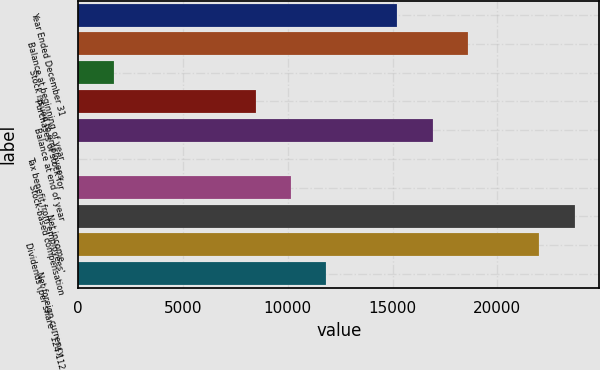Convert chart. <chart><loc_0><loc_0><loc_500><loc_500><bar_chart><fcel>Year Ended December 31<fcel>Balance at beginning of year<fcel>Stock issued to employees<fcel>Purchases of stock for<fcel>Balance at end of year<fcel>Tax benefit from employees'<fcel>Stock-based compensation<fcel>Net income<fcel>Dividends (per share - 124 112<fcel>Net foreign currency<nl><fcel>15228.3<fcel>18611.7<fcel>1694.7<fcel>8461.5<fcel>16920<fcel>3<fcel>10153.2<fcel>23686.8<fcel>21995.1<fcel>11844.9<nl></chart> 